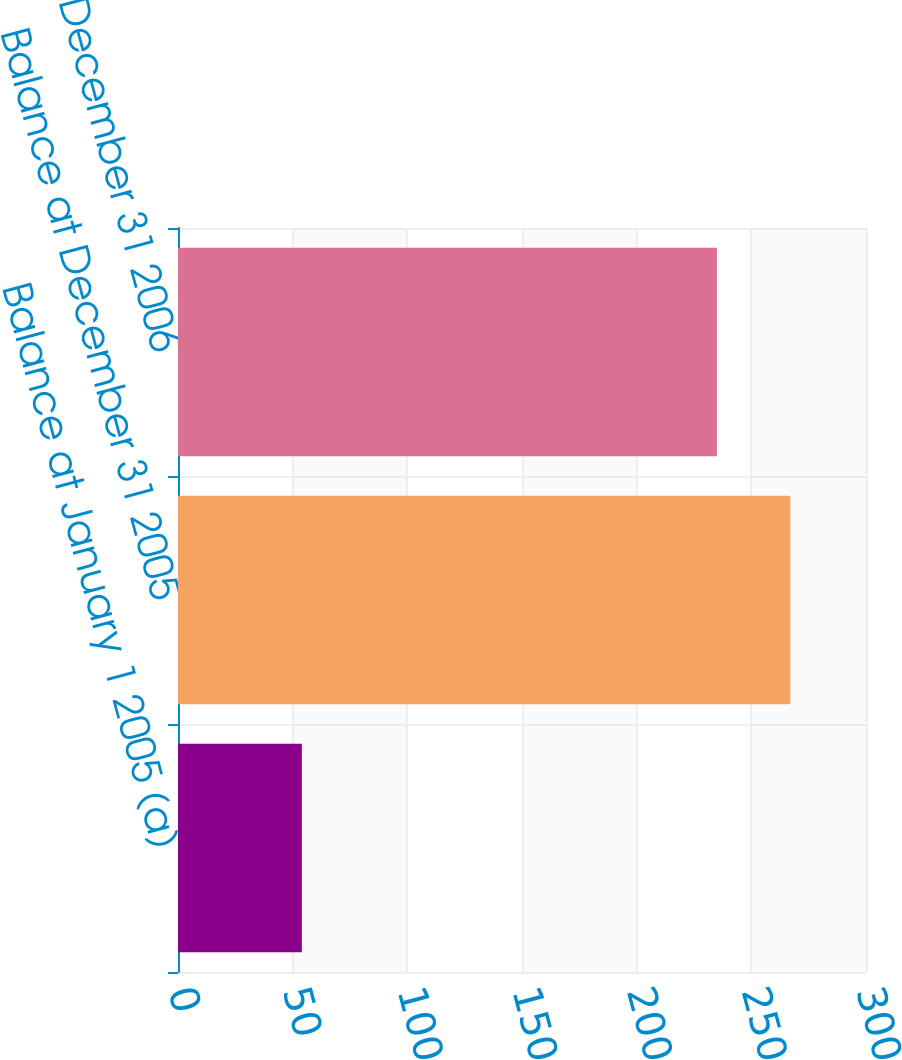Convert chart. <chart><loc_0><loc_0><loc_500><loc_500><bar_chart><fcel>Balance at January 1 2005 (a)<fcel>Balance at December 31 2005<fcel>Balance at December 31 2006<nl><fcel>54<fcel>267<fcel>235<nl></chart> 